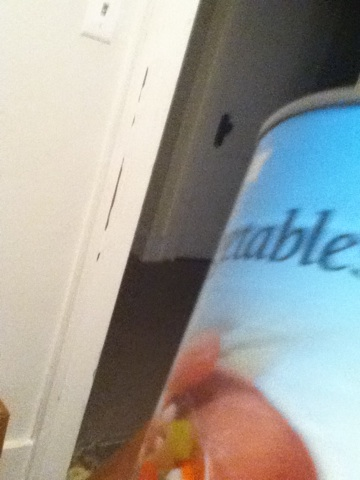Imagine if this can had magical properties, what kind of magic could it have? Imagine if this can of vegetables contained a potent, magical mix of ingredients that could grant superhuman strength and agility. Upon opening, it releases a radiant glow, and consuming even one bite from it makes you feel a surge of invigoration coursing through your veins. This magical can might be sought after by adventurers and heroes looking to gain an edge in their quests! 